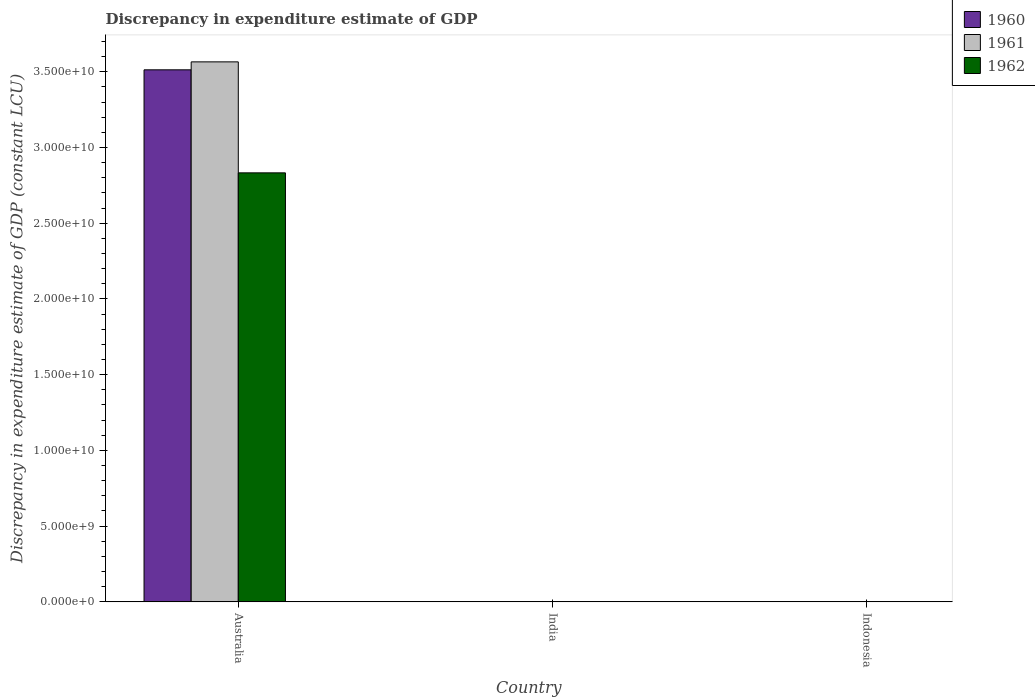How many different coloured bars are there?
Provide a succinct answer. 3. What is the label of the 2nd group of bars from the left?
Your answer should be compact. India. What is the discrepancy in expenditure estimate of GDP in 1962 in Indonesia?
Offer a very short reply. 0. Across all countries, what is the maximum discrepancy in expenditure estimate of GDP in 1961?
Your answer should be compact. 3.56e+1. Across all countries, what is the minimum discrepancy in expenditure estimate of GDP in 1960?
Your answer should be very brief. 0. What is the total discrepancy in expenditure estimate of GDP in 1962 in the graph?
Provide a succinct answer. 2.83e+1. What is the average discrepancy in expenditure estimate of GDP in 1960 per country?
Keep it short and to the point. 1.17e+1. What is the difference between the discrepancy in expenditure estimate of GDP of/in 1961 and discrepancy in expenditure estimate of GDP of/in 1962 in Australia?
Your answer should be compact. 7.33e+09. What is the difference between the highest and the lowest discrepancy in expenditure estimate of GDP in 1962?
Your answer should be very brief. 2.83e+1. Is it the case that in every country, the sum of the discrepancy in expenditure estimate of GDP in 1961 and discrepancy in expenditure estimate of GDP in 1962 is greater than the discrepancy in expenditure estimate of GDP in 1960?
Make the answer very short. No. Are all the bars in the graph horizontal?
Provide a short and direct response. No. How many countries are there in the graph?
Offer a terse response. 3. Are the values on the major ticks of Y-axis written in scientific E-notation?
Make the answer very short. Yes. Does the graph contain any zero values?
Keep it short and to the point. Yes. What is the title of the graph?
Keep it short and to the point. Discrepancy in expenditure estimate of GDP. Does "2011" appear as one of the legend labels in the graph?
Give a very brief answer. No. What is the label or title of the Y-axis?
Offer a terse response. Discrepancy in expenditure estimate of GDP (constant LCU). What is the Discrepancy in expenditure estimate of GDP (constant LCU) of 1960 in Australia?
Offer a very short reply. 3.51e+1. What is the Discrepancy in expenditure estimate of GDP (constant LCU) in 1961 in Australia?
Provide a succinct answer. 3.56e+1. What is the Discrepancy in expenditure estimate of GDP (constant LCU) in 1962 in Australia?
Your answer should be compact. 2.83e+1. What is the Discrepancy in expenditure estimate of GDP (constant LCU) of 1961 in India?
Provide a succinct answer. 0. What is the Discrepancy in expenditure estimate of GDP (constant LCU) of 1961 in Indonesia?
Provide a succinct answer. 0. Across all countries, what is the maximum Discrepancy in expenditure estimate of GDP (constant LCU) in 1960?
Your answer should be very brief. 3.51e+1. Across all countries, what is the maximum Discrepancy in expenditure estimate of GDP (constant LCU) in 1961?
Give a very brief answer. 3.56e+1. Across all countries, what is the maximum Discrepancy in expenditure estimate of GDP (constant LCU) in 1962?
Offer a terse response. 2.83e+1. Across all countries, what is the minimum Discrepancy in expenditure estimate of GDP (constant LCU) in 1960?
Make the answer very short. 0. Across all countries, what is the minimum Discrepancy in expenditure estimate of GDP (constant LCU) of 1961?
Your answer should be very brief. 0. Across all countries, what is the minimum Discrepancy in expenditure estimate of GDP (constant LCU) in 1962?
Your answer should be compact. 0. What is the total Discrepancy in expenditure estimate of GDP (constant LCU) in 1960 in the graph?
Make the answer very short. 3.51e+1. What is the total Discrepancy in expenditure estimate of GDP (constant LCU) in 1961 in the graph?
Provide a succinct answer. 3.56e+1. What is the total Discrepancy in expenditure estimate of GDP (constant LCU) in 1962 in the graph?
Your answer should be compact. 2.83e+1. What is the average Discrepancy in expenditure estimate of GDP (constant LCU) of 1960 per country?
Your answer should be compact. 1.17e+1. What is the average Discrepancy in expenditure estimate of GDP (constant LCU) in 1961 per country?
Your response must be concise. 1.19e+1. What is the average Discrepancy in expenditure estimate of GDP (constant LCU) in 1962 per country?
Give a very brief answer. 9.44e+09. What is the difference between the Discrepancy in expenditure estimate of GDP (constant LCU) of 1960 and Discrepancy in expenditure estimate of GDP (constant LCU) of 1961 in Australia?
Give a very brief answer. -5.25e+08. What is the difference between the Discrepancy in expenditure estimate of GDP (constant LCU) of 1960 and Discrepancy in expenditure estimate of GDP (constant LCU) of 1962 in Australia?
Give a very brief answer. 6.80e+09. What is the difference between the Discrepancy in expenditure estimate of GDP (constant LCU) in 1961 and Discrepancy in expenditure estimate of GDP (constant LCU) in 1962 in Australia?
Give a very brief answer. 7.33e+09. What is the difference between the highest and the lowest Discrepancy in expenditure estimate of GDP (constant LCU) of 1960?
Ensure brevity in your answer.  3.51e+1. What is the difference between the highest and the lowest Discrepancy in expenditure estimate of GDP (constant LCU) of 1961?
Your answer should be compact. 3.56e+1. What is the difference between the highest and the lowest Discrepancy in expenditure estimate of GDP (constant LCU) of 1962?
Provide a succinct answer. 2.83e+1. 